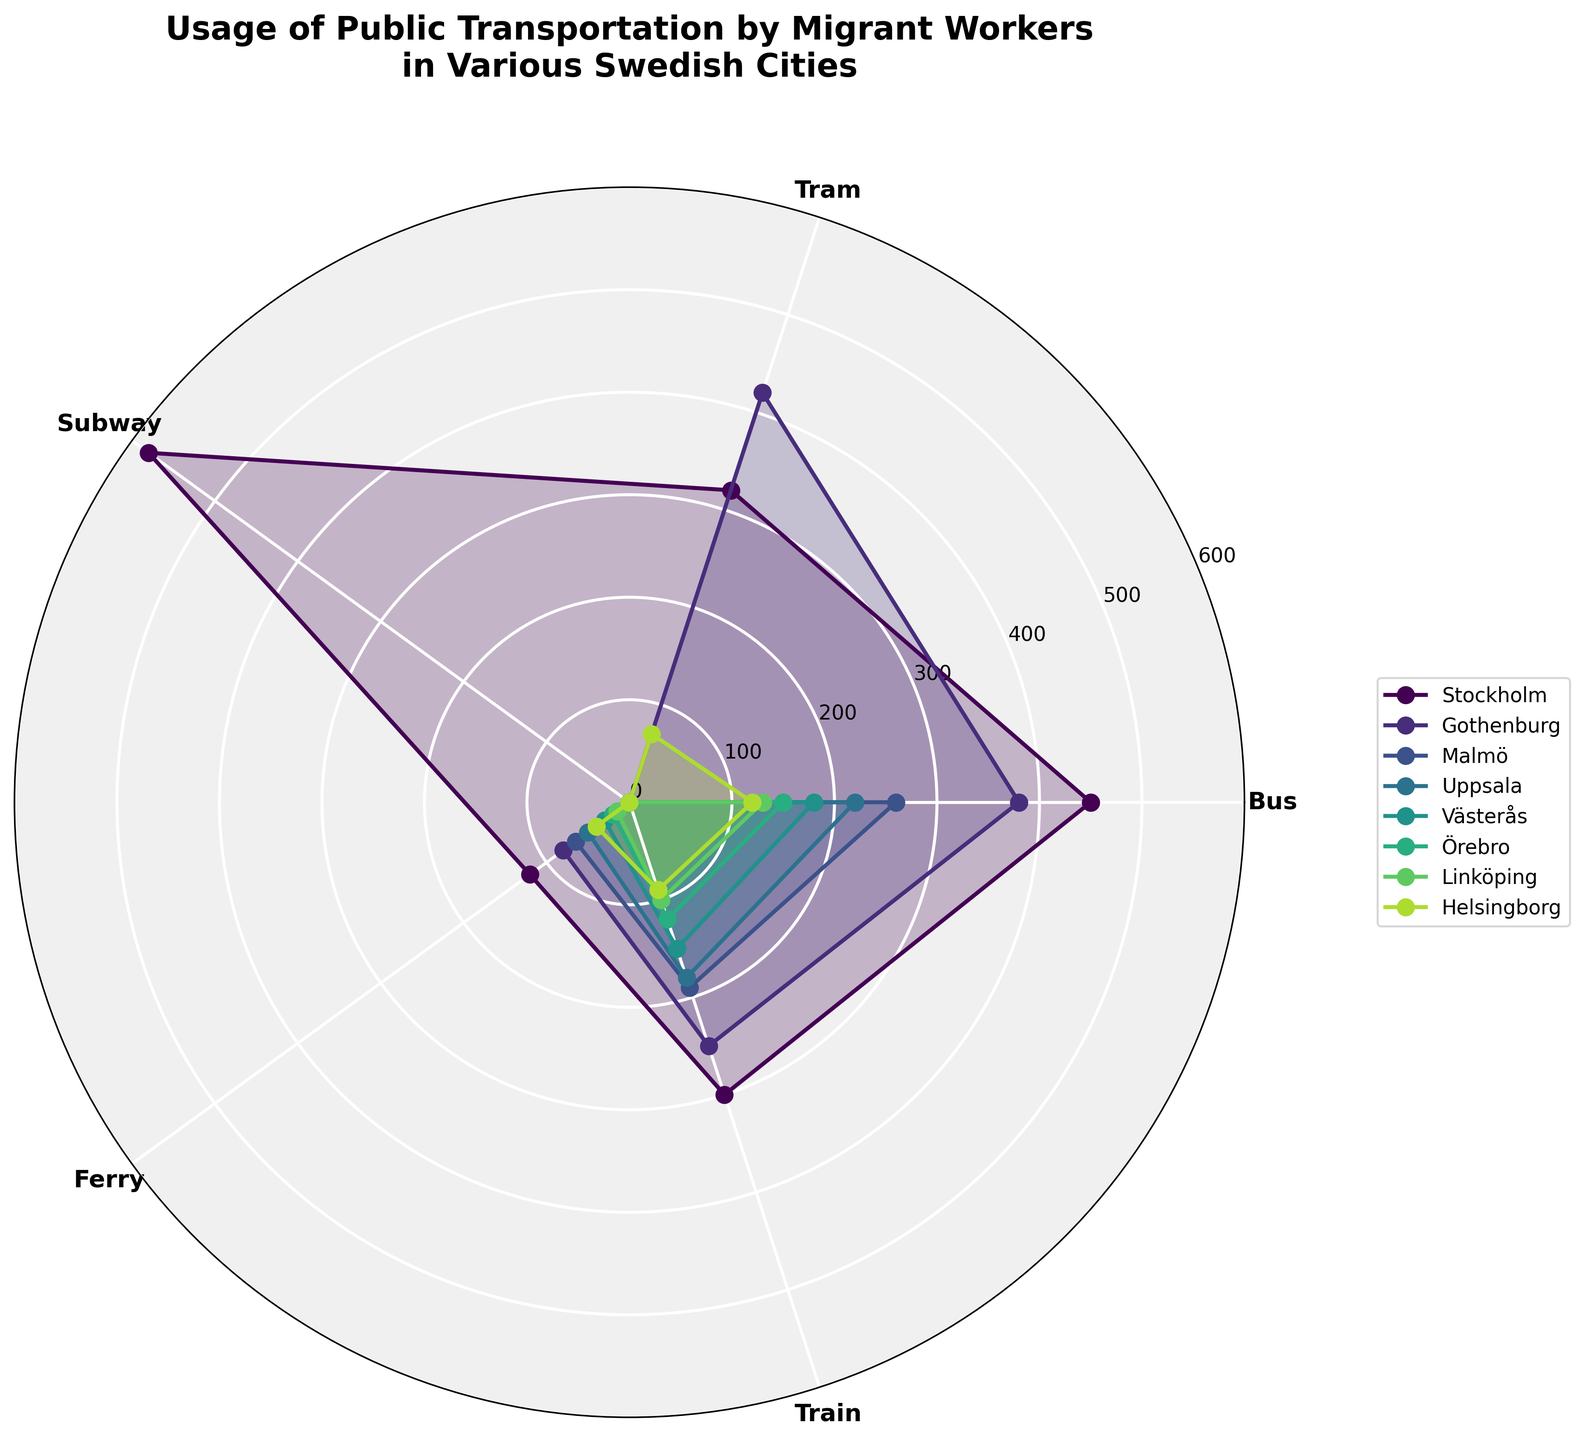What is the title of the polar area chart? The title is located at the top of the chart and summarizes the content of the figure. It reads 'Usage of Public Transportation by Migrant Workers in Various Swedish Cities'.
Answer: Usage of Public Transportation by Migrant Workers in Various Swedish Cities How many transport modes are shown in the chart? By looking at the labels on the chart axes, one can count the number of different transport modes listed around the circle. These modes are 'Bus', 'Tram', 'Subway', 'Ferry', and 'Train'.
Answer: 5 Which city has the highest usage of the subway and what is the value? By referencing the data points on the radial lines associated with the subway transport mode, Stockholm shows the highest usage, with a value that exceeds all other cities. This value is indicated next to the 'Subway' label.
Answer: Stockholm, 580 Which transport mode has the least total usage among all cities? Sum up the values of each transport mode across all cities and compare them. Tram and Ferry usage are generally lower, but Ferry usage (65 + 50 + 30 + 20 + 15 + 40 = 155) is the least.
Answer: Ferry Between Gothenburg and Malmö, which city has higher overall public transportation usage? By adding up the values of all transport modes for both cities, compare their totals. Sum for Gothenburg (380 + 420 + 0 + 80 + 250 = 1130) and for Malmö (260 + 0 + 0 + 65 + 190 = 515). Gothenburg has a higher overall usage.
Answer: Gothenburg Which cities do not use the subway at all? Identify cities with no lines extending from the central point to the 'Subway' label. By this visual cue, both Gothenburg, Malmö, Uppsala, Västerås, Örebro, Linköping, and Helsingborg show zero usage for the subway.
Answer: Gothenburg, Malmö, Uppsala, Västerås, Örebro, Linköping, Helsingborg What is the most common form of public transportation among the migrant workers in all cities combined? Compare the usage values of each transport mode across all cities. The highest collective value will indicate the most common transport mode. Summing the values for all transport modes, Bus usage (450 + 380 + 260 + 220 + 180 + 150 + 130 + 120 = 1890) is the highest.
Answer: Bus Which city shows the most balanced usage of different transport modes? Compare the shapes of the filled areas for each city. The city with the most uniform-distance spikes from the center to the edge of the figure across different transport modes is most balanced. Helsingborg shows a relatively even distribution across Bus, Tram, Ferry, and Train, without any extreme spikes.
Answer: Helsingborg If you consider only Bus and Train, which city has the highest combined usage, and what is that value? Sum the values of Bus and Train for each city and identify which is the highest. Stockholm: 450 + 300 = 750; Gothenburg: 380 + 250 = 630; Malmö: 260 + 190 = 450, and so on. The highest combined value is for Stockholm.
Answer: Stockholm, 750 